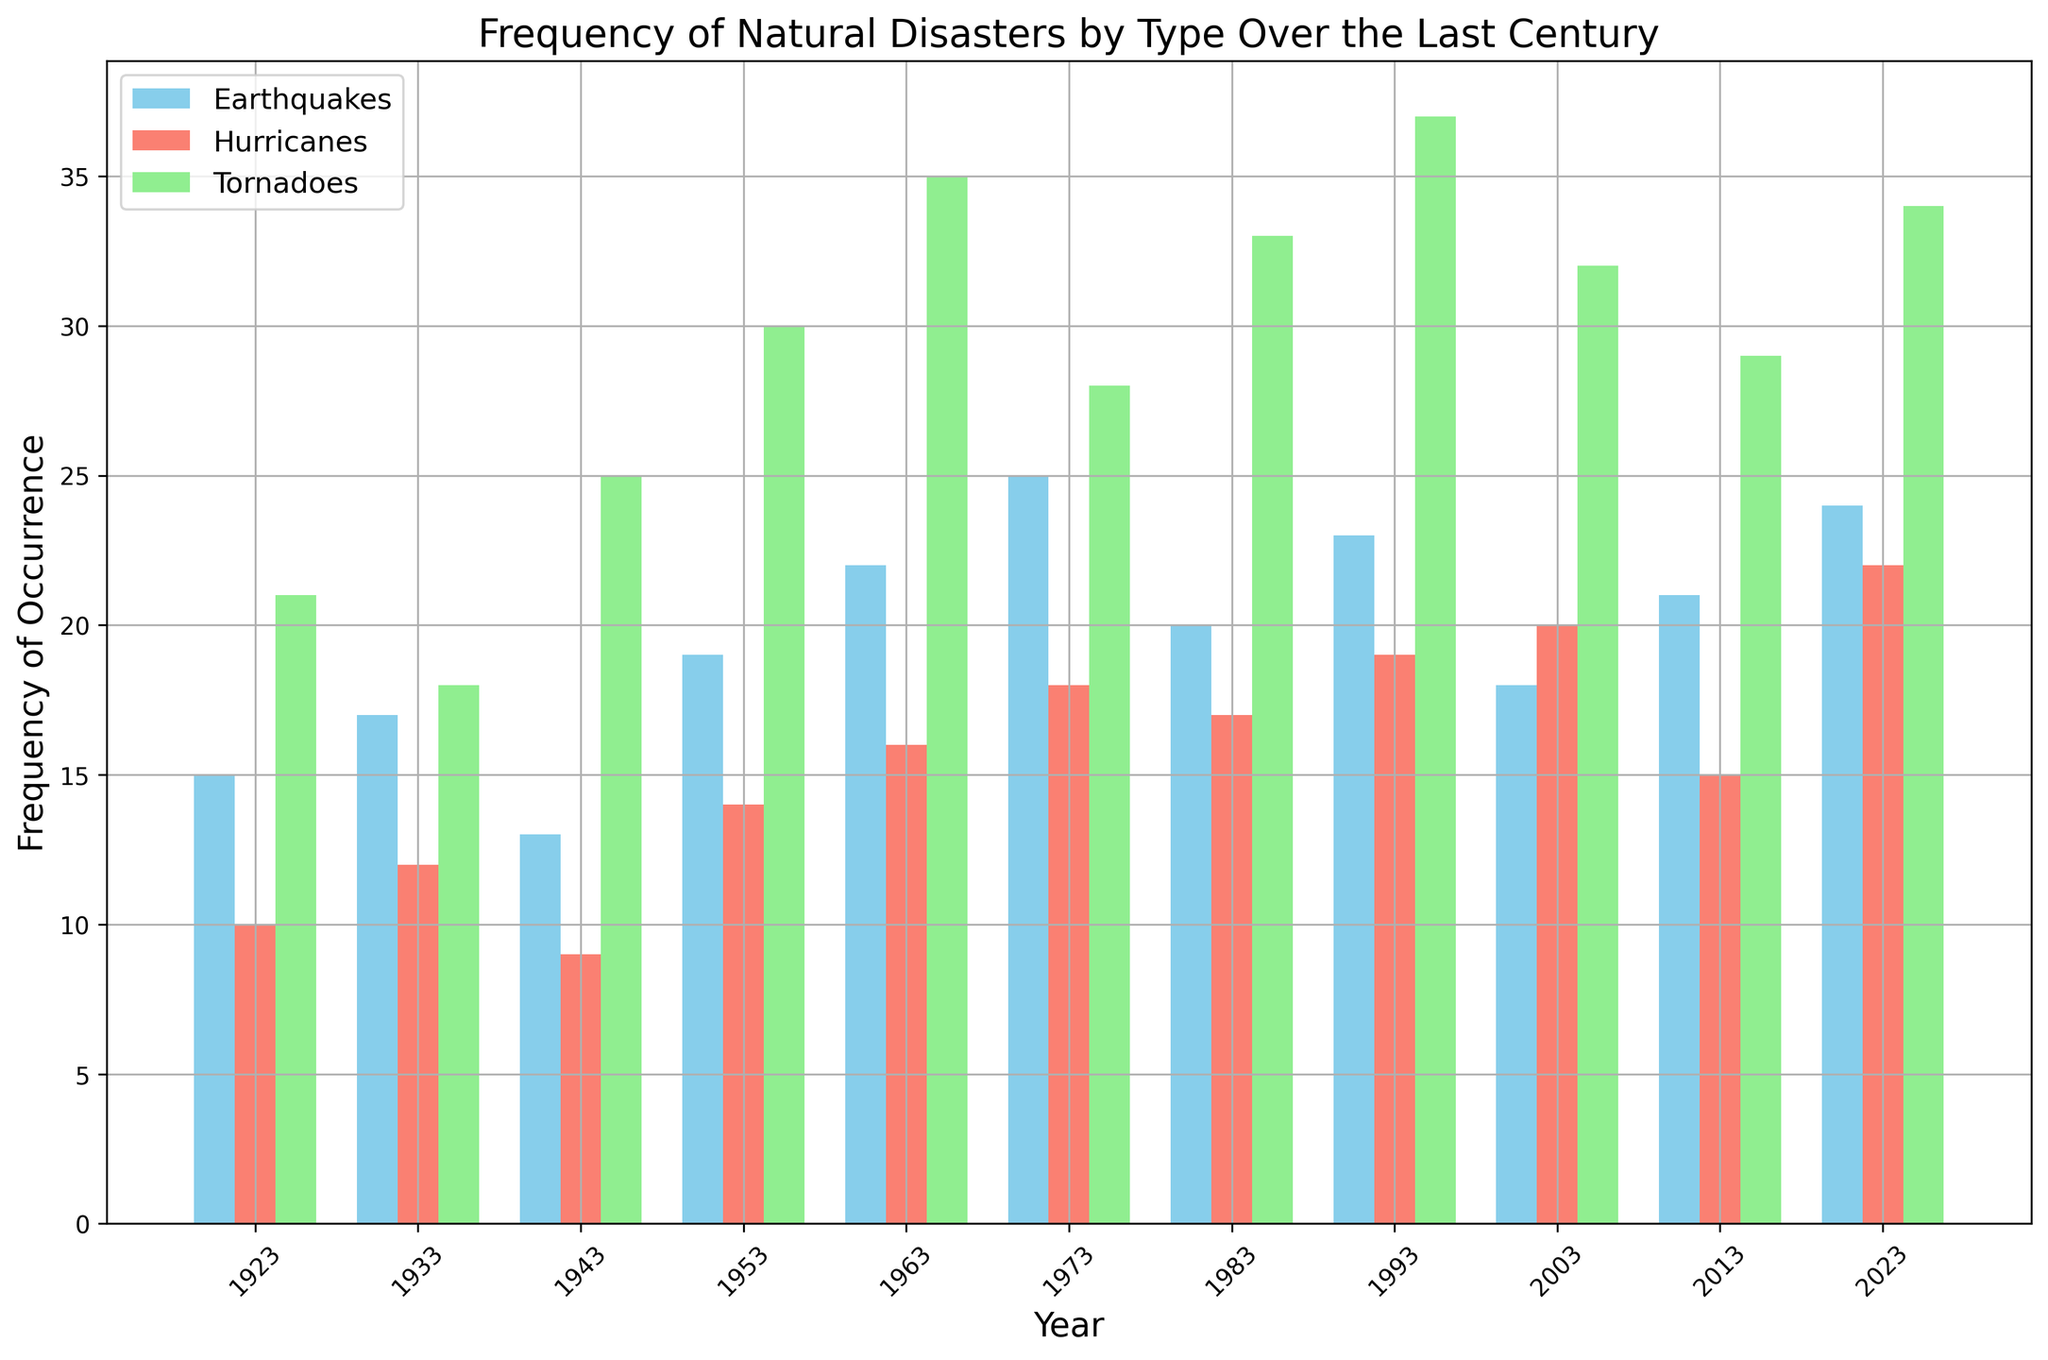Which type of natural disaster had the highest frequency of occurrence in 2023? To find which type of natural disaster had the highest frequency, look at the top of the bars for the year 2023. The tallest bar indicates the type with the highest frequency.
Answer: Tornado Between 1953 and 1983, how did the frequency of hurricanes change? Compare the height of the hurricane bars (red) for the years 1953 and 1983. Specifically, we look for any increase or decrease between these two years. Hurricane occurrences increased from 14 to 17.
Answer: Increased What is the average frequency of earthquakes over the century? Add the frequency of earthquakes for all the years provided and then divide by the number of data points (11 years). (15+17+13+19+22+25+20+23+18+21+24)/11 = 19.36
Answer: 19.36 Which year had the smallest combined frequency of all three types of natural disasters? Add the frequencies for earthquakes, hurricanes, and tornadoes for each year, and compare the summed values to find the smallest total. The year 1943 has the smallest total (13 + 9 + 25 = 47).
Answer: 1943 Which natural disaster type experienced the greatest increase in frequency from 1943 to 1973? Calculate the difference in frequencies for each type between the years 1943 and 1973: Earthquakes (25-13=12), Hurricanes (18-9=9), and Tornadoes (28-25=3). Earthquakes experienced the greatest increase.
Answer: Earthquake From 2003 to 2023, how did the frequency of tornado occurrences change? Compare the height of the tornado bars (green) for the years 2003 and 2023. Tornado occurrences increased from 32 to 34.
Answer: Increased Which type of natural disaster shows the most stable frequency trend over the century? To determine stability, observe the relative consistency of the bar heights for each type. Hurricanes (red bars) show relatively smaller fluctuations compared to earthquakes and tornadoes.
Answer: Hurricanes How does the frequency of hurricanes in 2013 compare to that in 1953? Examine the height of the hurricane bars (red) for the years 2013 and 1953. The occurrences decreased from 14 in 1953 to 15 in 2013.
Answer: Decreased 